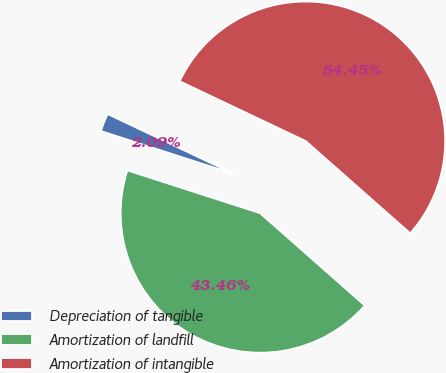Convert chart to OTSL. <chart><loc_0><loc_0><loc_500><loc_500><pie_chart><fcel>Depreciation of tangible<fcel>Amortization of landfill<fcel>Amortization of intangible<nl><fcel>2.09%<fcel>43.46%<fcel>54.45%<nl></chart> 